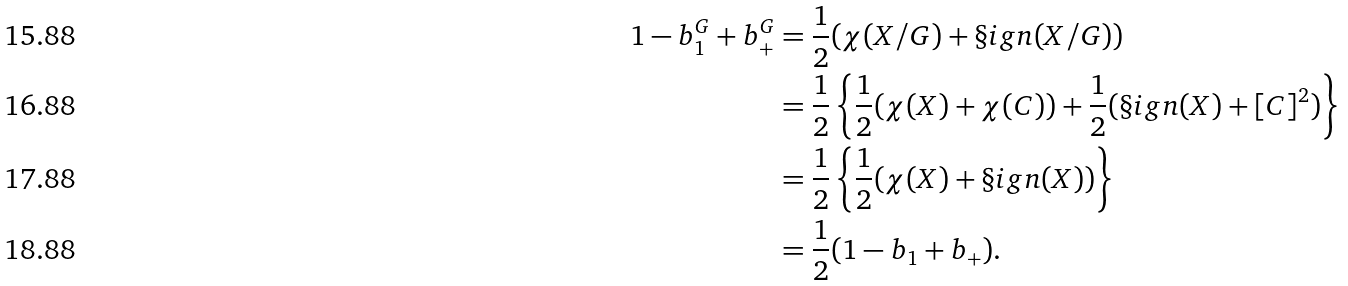Convert formula to latex. <formula><loc_0><loc_0><loc_500><loc_500>1 - b _ { 1 } ^ { G } + b _ { + } ^ { G } & = \frac { 1 } { 2 } ( \chi ( X / G ) + \S i g n ( X / G ) ) \\ & = \frac { 1 } { 2 } \left \{ \frac { 1 } { 2 } ( \chi ( X ) + \chi ( C ) ) + \frac { 1 } { 2 } ( \S i g n ( X ) + [ C ] ^ { 2 } ) \right \} \\ & = \frac { 1 } { 2 } \left \{ \frac { 1 } { 2 } ( \chi ( X ) + \S i g n ( X ) ) \right \} \\ & = \frac { 1 } { 2 } ( 1 - b _ { 1 } + b _ { + } ) .</formula> 